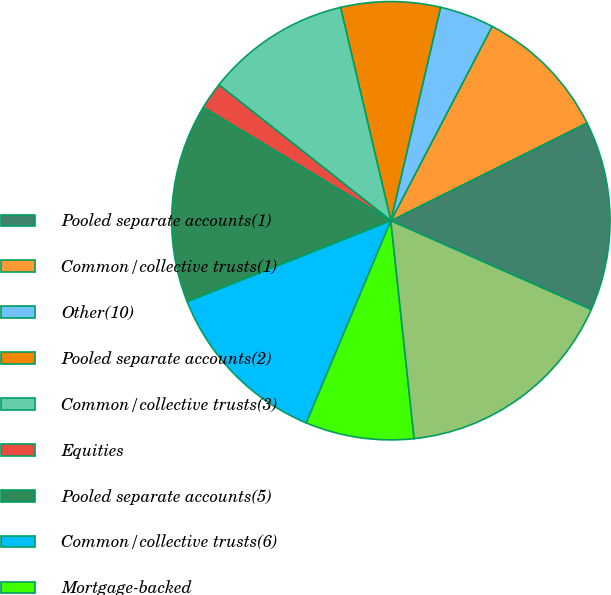<chart> <loc_0><loc_0><loc_500><loc_500><pie_chart><fcel>Pooled separate accounts(1)<fcel>Common/collective trusts(1)<fcel>Other(10)<fcel>Pooled separate accounts(2)<fcel>Common/collective trusts(3)<fcel>Equities<fcel>Pooled separate accounts(5)<fcel>Common/collective trusts(6)<fcel>Mortgage-backed<fcel>Other US government securities<nl><fcel>14.0%<fcel>10.0%<fcel>4.0%<fcel>7.33%<fcel>10.67%<fcel>2.0%<fcel>14.67%<fcel>12.67%<fcel>8.0%<fcel>16.67%<nl></chart> 